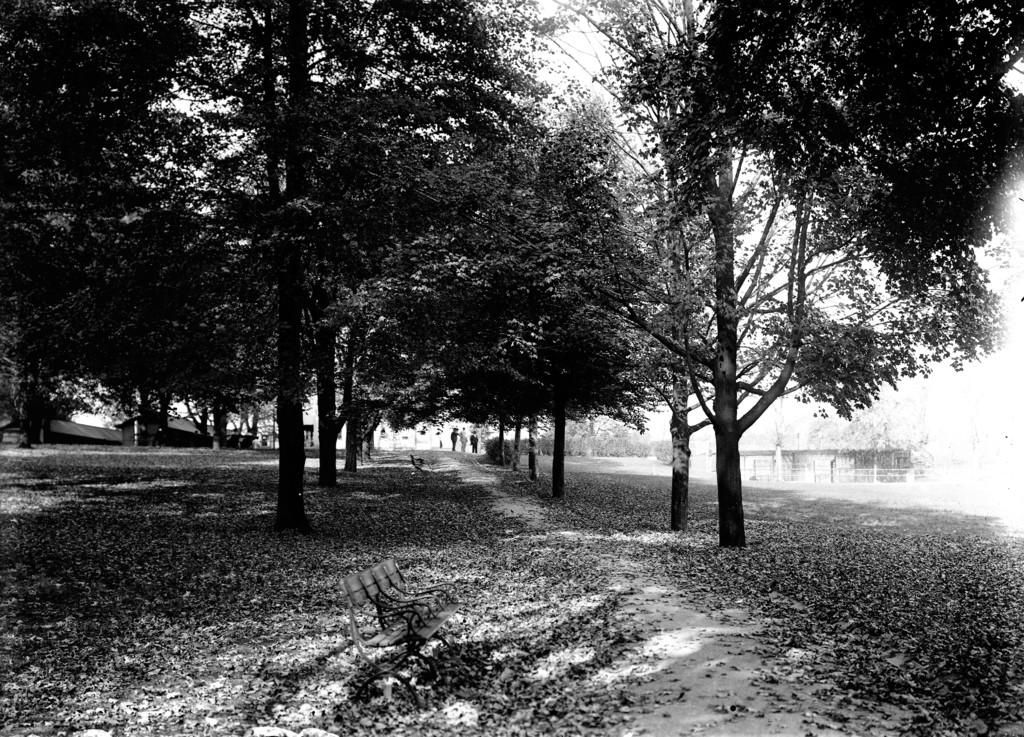What is the color scheme of the image? The image is black and white. What type of natural elements can be seen in the image? There are trees in the image. What type of structures are present in the image? There are sheds in the image. Who or what is present in the image? There are people in the image. What type of seating is available in the image? There are benches in the image. What is present on the ground at the bottom of the image? Leaves are present on the ground at the bottom of the image. What type of breakfast is being served on the stage in the image? There is no stage or breakfast present in the image; it features trees, sheds, people, benches, and leaves on the ground. 